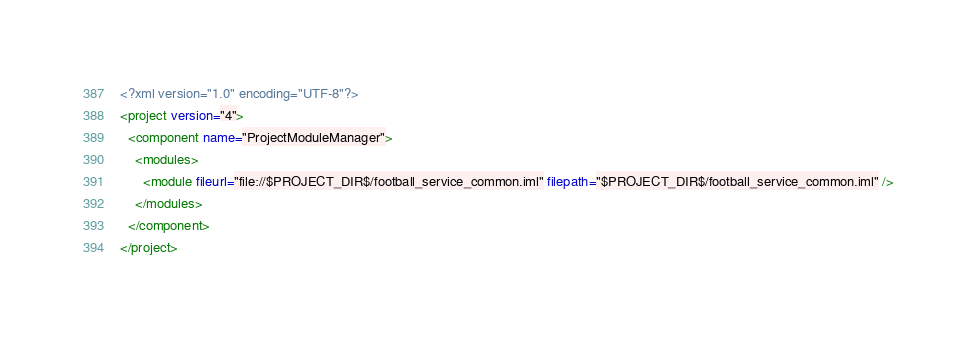Convert code to text. <code><loc_0><loc_0><loc_500><loc_500><_XML_><?xml version="1.0" encoding="UTF-8"?>
<project version="4">
  <component name="ProjectModuleManager">
    <modules>
      <module fileurl="file://$PROJECT_DIR$/football_service_common.iml" filepath="$PROJECT_DIR$/football_service_common.iml" />
    </modules>
  </component>
</project></code> 